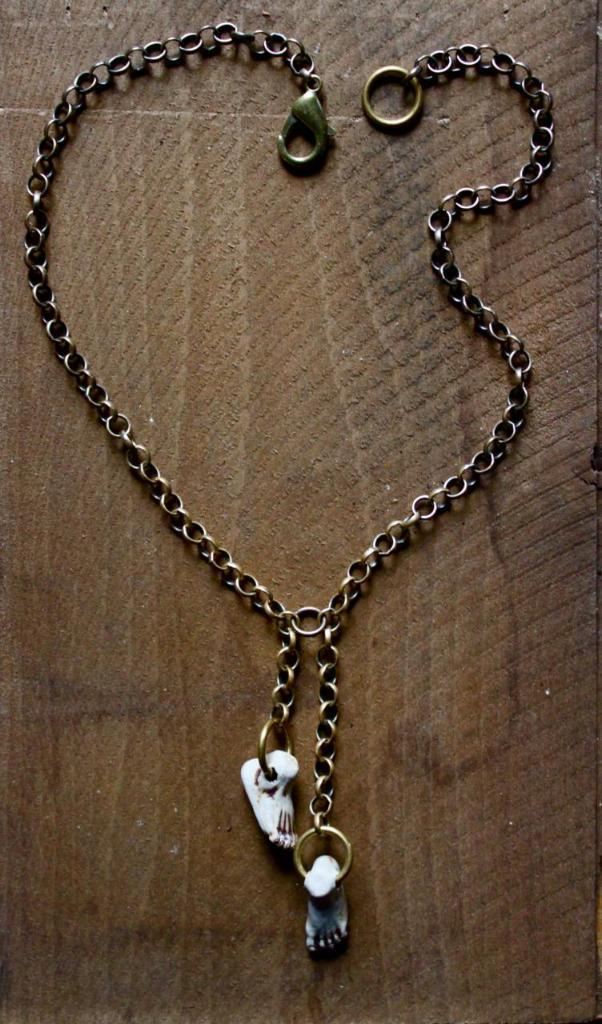What is on the wooden surface in the image? There is a chain and a dollar on the wooden surface. Can you describe the chain in more detail? The chain is on the wooden surface, but no further details about its length, material, or appearance are provided. How many pigs are visible in the image? There are no pigs present in the image. What advice does the father give in the image? There is no father or any dialogue present in the image, so it is not possible to answer this question. 